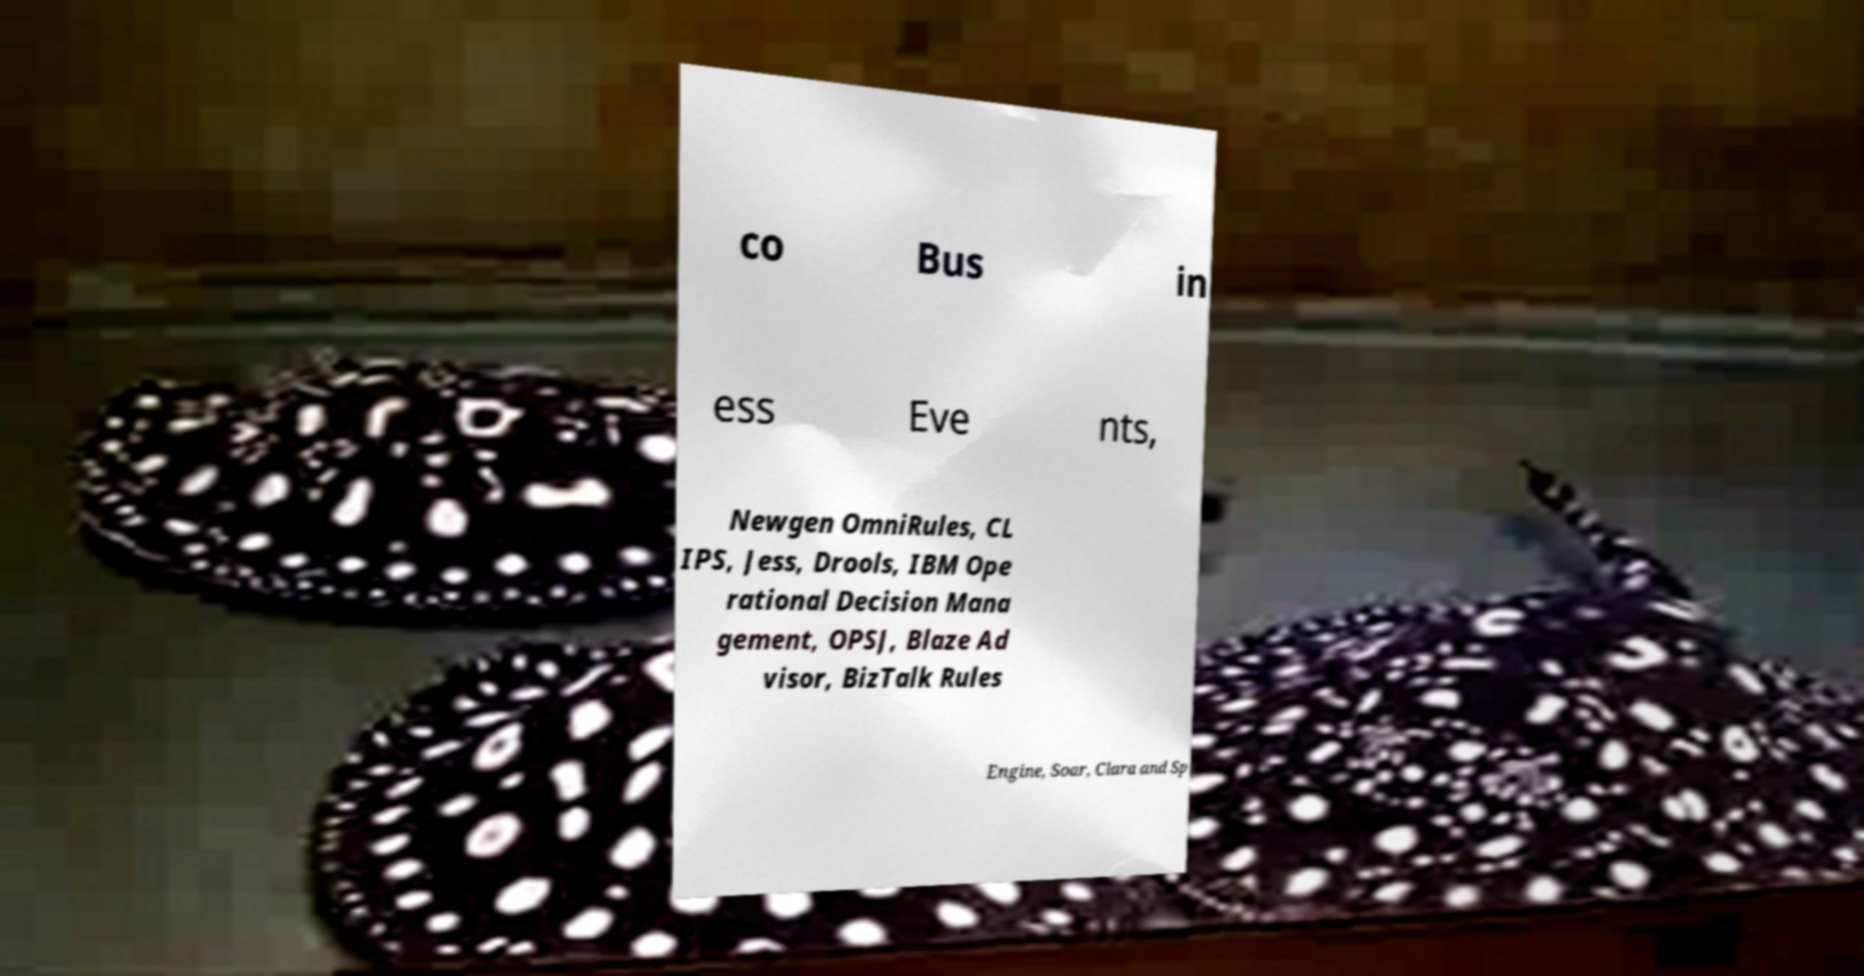Could you extract and type out the text from this image? co Bus in ess Eve nts, Newgen OmniRules, CL IPS, Jess, Drools, IBM Ope rational Decision Mana gement, OPSJ, Blaze Ad visor, BizTalk Rules Engine, Soar, Clara and Sp 